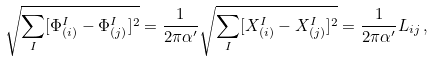Convert formula to latex. <formula><loc_0><loc_0><loc_500><loc_500>\sqrt { \sum _ { I } [ \Phi ^ { I } _ { ( i ) } - \Phi ^ { I } _ { ( j ) } ] ^ { 2 } } = \frac { 1 } { 2 \pi \alpha ^ { \prime } } \sqrt { \sum _ { I } [ X ^ { I } _ { ( i ) } - X ^ { I } _ { ( j ) } ] ^ { 2 } } = \frac { 1 } { 2 \pi \alpha ^ { \prime } } L _ { i j } \, ,</formula> 